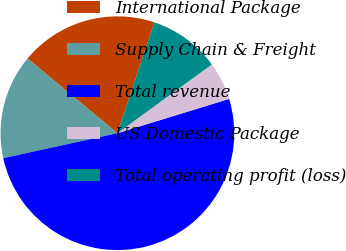Convert chart to OTSL. <chart><loc_0><loc_0><loc_500><loc_500><pie_chart><fcel>International Package<fcel>Supply Chain & Freight<fcel>Total revenue<fcel>US Domestic Package<fcel>Total operating profit (loss)<nl><fcel>19.08%<fcel>14.47%<fcel>51.31%<fcel>5.27%<fcel>9.87%<nl></chart> 